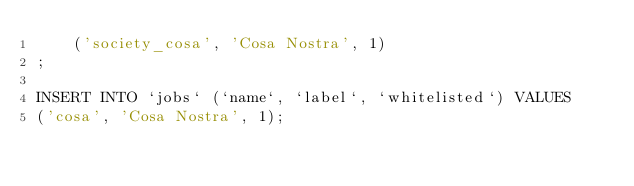<code> <loc_0><loc_0><loc_500><loc_500><_SQL_>	('society_cosa', 'Cosa Nostra', 1)
;

INSERT INTO `jobs` (`name`, `label`, `whitelisted`) VALUES
('cosa', 'Cosa Nostra', 1);

</code> 